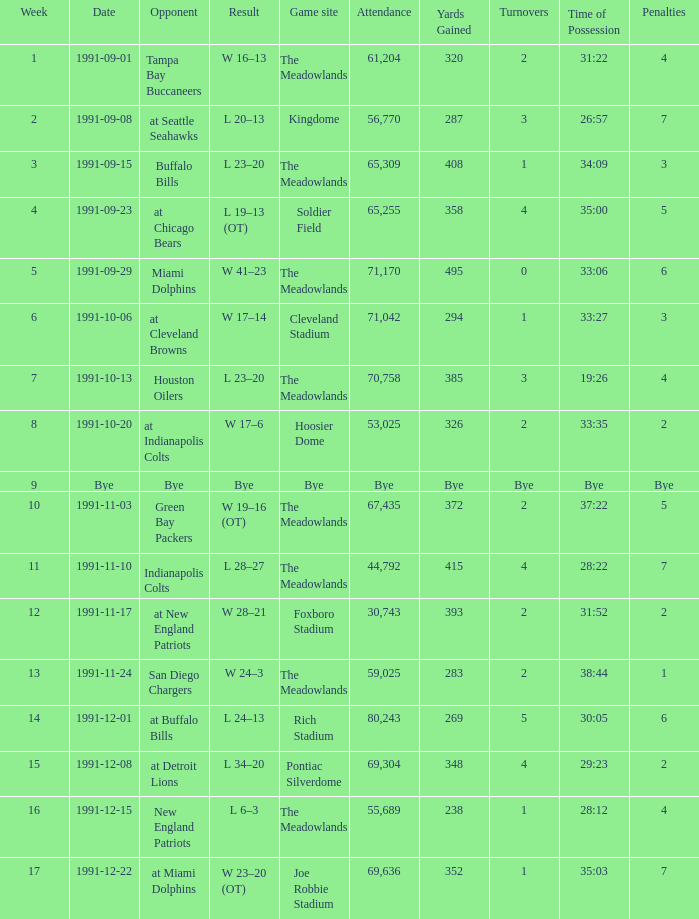Which Opponent was played on 1991-10-13? Houston Oilers. 